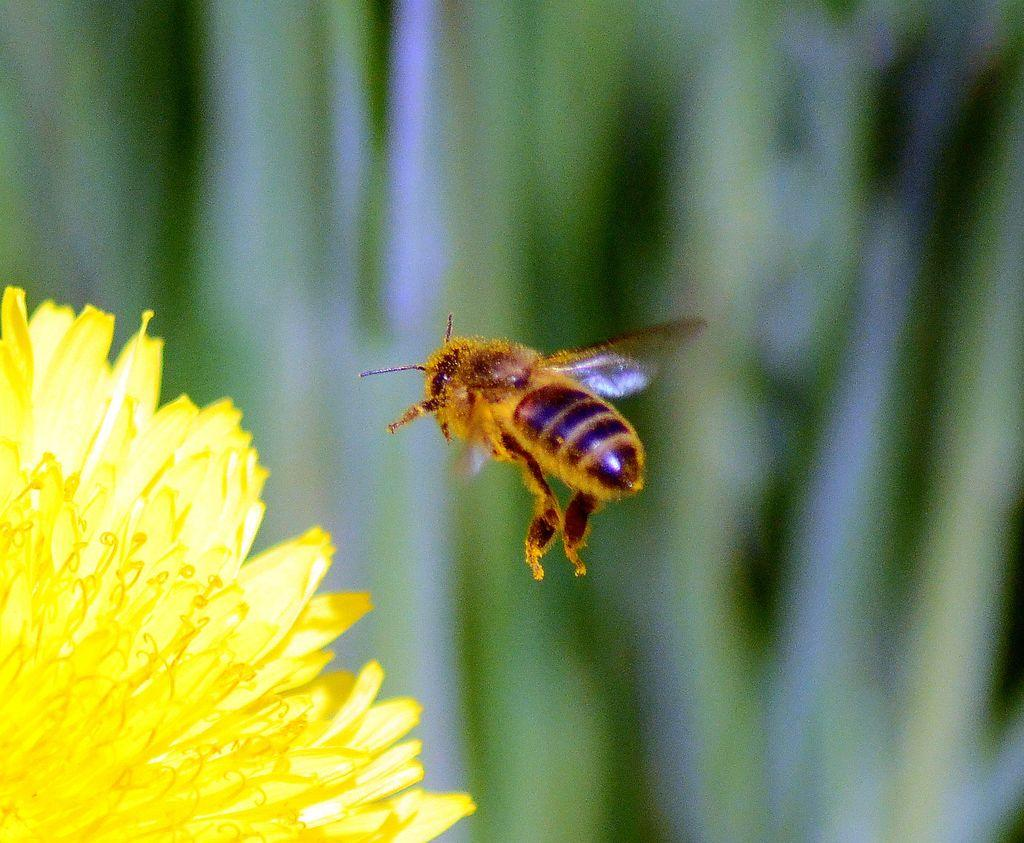What is located on the left side of the image? There is a flower on the left side of the image. What can be seen in the center of the image? There is a bee in the center of the image. What type of vegetation is visible in the background of the image? There are plants in the background of the image. How does the bear contribute to the news in the image? There is no bear or news present in the image; it features a flower and a bee. What type of fire can be seen burning in the image? There is no fire or burn present in the image; it features a flower, a bee, and plants in the background. 